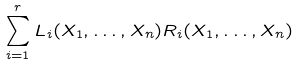Convert formula to latex. <formula><loc_0><loc_0><loc_500><loc_500>\sum _ { i = 1 } ^ { r } L _ { i } ( X _ { 1 } , \dots , X _ { n } ) R _ { i } ( X _ { 1 } , \dots , X _ { n } )</formula> 